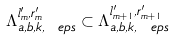<formula> <loc_0><loc_0><loc_500><loc_500>\Lambda _ { a , b , k , \ e p s } ^ { l ^ { \prime } _ { m } , r ^ { \prime } _ { m } } \subset \Lambda _ { a , b , k , \ e p s } ^ { l ^ { \prime } _ { m + 1 } , r ^ { \prime } _ { m + 1 } }</formula> 